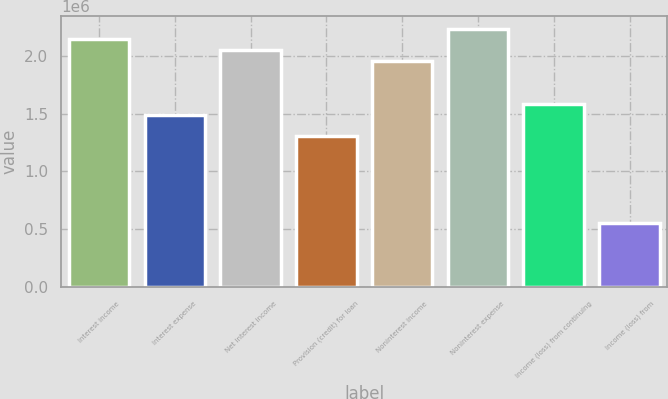Convert chart to OTSL. <chart><loc_0><loc_0><loc_500><loc_500><bar_chart><fcel>Interest income<fcel>Interest expense<fcel>Net interest income<fcel>Provision (credit) for loan<fcel>Noninterest income<fcel>Noninterest expense<fcel>Income (loss) from continuing<fcel>Income (loss) from<nl><fcel>2.13988e+06<fcel>1.48861e+06<fcel>2.04684e+06<fcel>1.30253e+06<fcel>1.9538e+06<fcel>2.23292e+06<fcel>1.58165e+06<fcel>558229<nl></chart> 